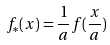Convert formula to latex. <formula><loc_0><loc_0><loc_500><loc_500>f _ { * } ( x ) = \frac { 1 } { a } f ( \frac { x } { a } )</formula> 